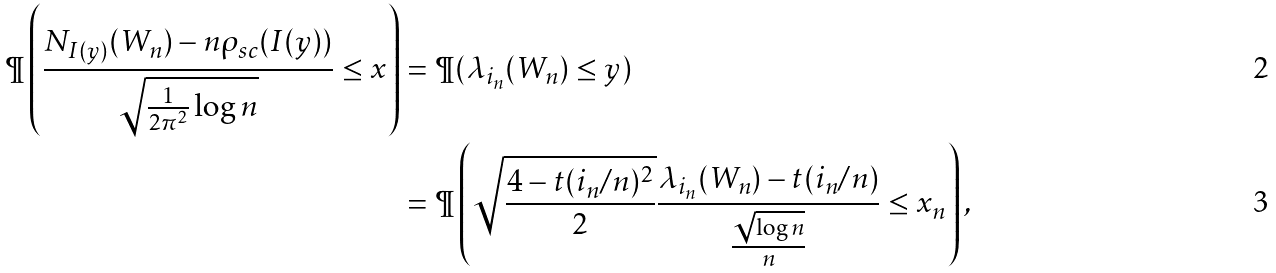Convert formula to latex. <formula><loc_0><loc_0><loc_500><loc_500>\P \left ( \frac { N _ { I ( y ) } ( W _ { n } ) - n \rho _ { s c } ( I ( y ) ) } { \sqrt { \frac { 1 } { 2 \pi ^ { 2 } } \log n } } \leq x \right ) & = \P ( \lambda _ { i _ { n } } ( W _ { n } ) \leq y ) \\ & = \P \left ( \sqrt { \frac { 4 - t ( i _ { n } / n ) ^ { 2 } } { 2 } } \frac { \lambda _ { i _ { n } } ( W _ { n } ) - t ( i _ { n } / n ) } { \frac { \sqrt { \log n } } { n } } \leq x _ { n } \right ) ,</formula> 